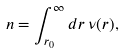Convert formula to latex. <formula><loc_0><loc_0><loc_500><loc_500>n = \int _ { r _ { 0 } } ^ { \infty } d r \, \nu ( r ) ,</formula> 